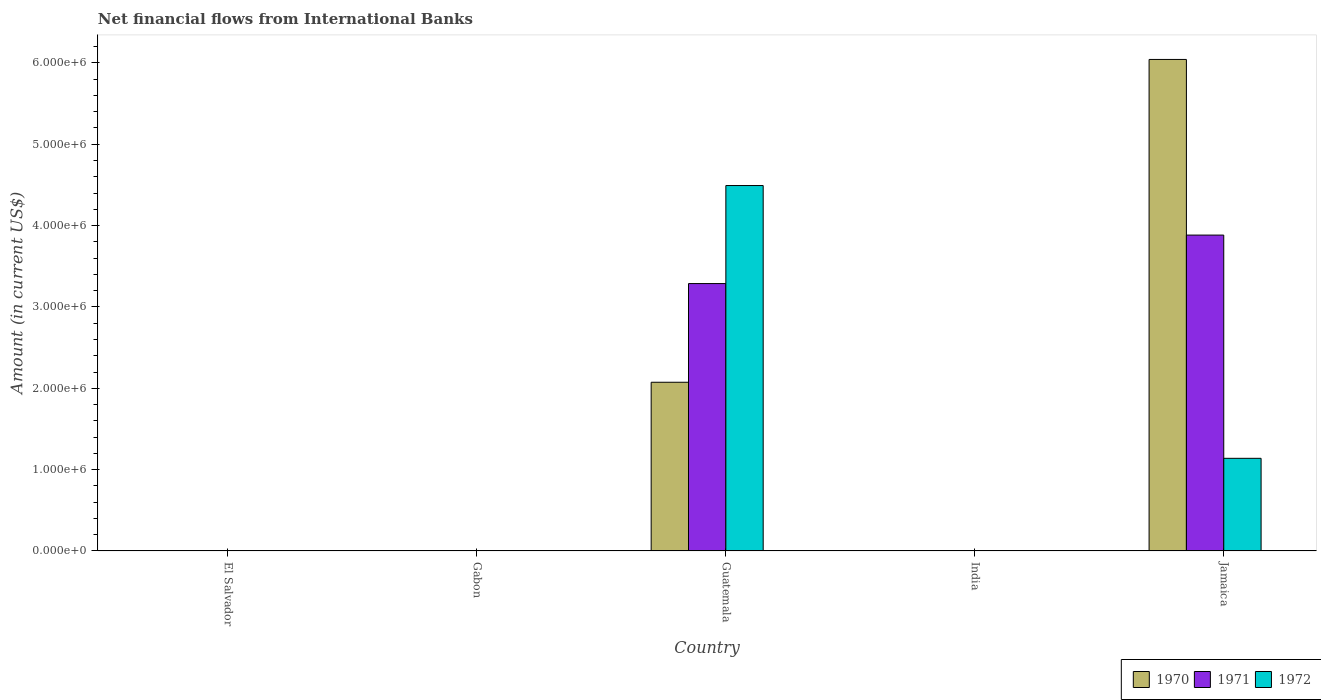How many different coloured bars are there?
Your answer should be very brief. 3. Are the number of bars per tick equal to the number of legend labels?
Your response must be concise. No. How many bars are there on the 3rd tick from the right?
Your response must be concise. 3. What is the label of the 2nd group of bars from the left?
Offer a very short reply. Gabon. In how many cases, is the number of bars for a given country not equal to the number of legend labels?
Ensure brevity in your answer.  3. Across all countries, what is the maximum net financial aid flows in 1972?
Give a very brief answer. 4.49e+06. Across all countries, what is the minimum net financial aid flows in 1972?
Ensure brevity in your answer.  0. In which country was the net financial aid flows in 1972 maximum?
Offer a very short reply. Guatemala. What is the total net financial aid flows in 1970 in the graph?
Provide a succinct answer. 8.12e+06. What is the difference between the net financial aid flows in 1971 in Guatemala and that in Jamaica?
Offer a very short reply. -5.96e+05. What is the average net financial aid flows in 1970 per country?
Your answer should be compact. 1.62e+06. What is the difference between the net financial aid flows of/in 1971 and net financial aid flows of/in 1972 in Jamaica?
Provide a succinct answer. 2.74e+06. What is the ratio of the net financial aid flows in 1972 in Guatemala to that in Jamaica?
Make the answer very short. 3.94. What is the difference between the highest and the lowest net financial aid flows in 1971?
Offer a terse response. 3.88e+06. Is the sum of the net financial aid flows in 1971 in Guatemala and Jamaica greater than the maximum net financial aid flows in 1972 across all countries?
Ensure brevity in your answer.  Yes. Is it the case that in every country, the sum of the net financial aid flows in 1972 and net financial aid flows in 1971 is greater than the net financial aid flows in 1970?
Ensure brevity in your answer.  No. How many countries are there in the graph?
Provide a short and direct response. 5. What is the difference between two consecutive major ticks on the Y-axis?
Offer a very short reply. 1.00e+06. Are the values on the major ticks of Y-axis written in scientific E-notation?
Your response must be concise. Yes. Does the graph contain grids?
Give a very brief answer. No. How are the legend labels stacked?
Offer a terse response. Horizontal. What is the title of the graph?
Your answer should be very brief. Net financial flows from International Banks. Does "2003" appear as one of the legend labels in the graph?
Ensure brevity in your answer.  No. What is the label or title of the X-axis?
Provide a short and direct response. Country. What is the label or title of the Y-axis?
Provide a succinct answer. Amount (in current US$). What is the Amount (in current US$) of 1971 in El Salvador?
Provide a succinct answer. 0. What is the Amount (in current US$) of 1972 in Gabon?
Offer a terse response. 0. What is the Amount (in current US$) of 1970 in Guatemala?
Your response must be concise. 2.07e+06. What is the Amount (in current US$) of 1971 in Guatemala?
Your response must be concise. 3.29e+06. What is the Amount (in current US$) of 1972 in Guatemala?
Offer a terse response. 4.49e+06. What is the Amount (in current US$) in 1971 in India?
Offer a very short reply. 0. What is the Amount (in current US$) in 1972 in India?
Your answer should be compact. 0. What is the Amount (in current US$) in 1970 in Jamaica?
Give a very brief answer. 6.04e+06. What is the Amount (in current US$) of 1971 in Jamaica?
Offer a very short reply. 3.88e+06. What is the Amount (in current US$) of 1972 in Jamaica?
Your answer should be compact. 1.14e+06. Across all countries, what is the maximum Amount (in current US$) in 1970?
Your response must be concise. 6.04e+06. Across all countries, what is the maximum Amount (in current US$) of 1971?
Ensure brevity in your answer.  3.88e+06. Across all countries, what is the maximum Amount (in current US$) in 1972?
Give a very brief answer. 4.49e+06. Across all countries, what is the minimum Amount (in current US$) in 1970?
Ensure brevity in your answer.  0. Across all countries, what is the minimum Amount (in current US$) of 1972?
Your response must be concise. 0. What is the total Amount (in current US$) in 1970 in the graph?
Offer a very short reply. 8.12e+06. What is the total Amount (in current US$) of 1971 in the graph?
Provide a succinct answer. 7.17e+06. What is the total Amount (in current US$) in 1972 in the graph?
Your answer should be compact. 5.63e+06. What is the difference between the Amount (in current US$) of 1970 in Guatemala and that in Jamaica?
Your answer should be very brief. -3.97e+06. What is the difference between the Amount (in current US$) of 1971 in Guatemala and that in Jamaica?
Give a very brief answer. -5.96e+05. What is the difference between the Amount (in current US$) in 1972 in Guatemala and that in Jamaica?
Ensure brevity in your answer.  3.35e+06. What is the difference between the Amount (in current US$) of 1970 in Guatemala and the Amount (in current US$) of 1971 in Jamaica?
Your answer should be very brief. -1.81e+06. What is the difference between the Amount (in current US$) of 1970 in Guatemala and the Amount (in current US$) of 1972 in Jamaica?
Your answer should be very brief. 9.35e+05. What is the difference between the Amount (in current US$) of 1971 in Guatemala and the Amount (in current US$) of 1972 in Jamaica?
Provide a succinct answer. 2.15e+06. What is the average Amount (in current US$) in 1970 per country?
Your answer should be compact. 1.62e+06. What is the average Amount (in current US$) in 1971 per country?
Your response must be concise. 1.43e+06. What is the average Amount (in current US$) in 1972 per country?
Offer a very short reply. 1.13e+06. What is the difference between the Amount (in current US$) of 1970 and Amount (in current US$) of 1971 in Guatemala?
Provide a succinct answer. -1.21e+06. What is the difference between the Amount (in current US$) in 1970 and Amount (in current US$) in 1972 in Guatemala?
Provide a succinct answer. -2.42e+06. What is the difference between the Amount (in current US$) of 1971 and Amount (in current US$) of 1972 in Guatemala?
Provide a succinct answer. -1.20e+06. What is the difference between the Amount (in current US$) in 1970 and Amount (in current US$) in 1971 in Jamaica?
Provide a short and direct response. 2.16e+06. What is the difference between the Amount (in current US$) of 1970 and Amount (in current US$) of 1972 in Jamaica?
Ensure brevity in your answer.  4.90e+06. What is the difference between the Amount (in current US$) of 1971 and Amount (in current US$) of 1972 in Jamaica?
Provide a succinct answer. 2.74e+06. What is the ratio of the Amount (in current US$) in 1970 in Guatemala to that in Jamaica?
Provide a short and direct response. 0.34. What is the ratio of the Amount (in current US$) in 1971 in Guatemala to that in Jamaica?
Provide a succinct answer. 0.85. What is the ratio of the Amount (in current US$) of 1972 in Guatemala to that in Jamaica?
Make the answer very short. 3.94. What is the difference between the highest and the lowest Amount (in current US$) in 1970?
Your answer should be very brief. 6.04e+06. What is the difference between the highest and the lowest Amount (in current US$) of 1971?
Your answer should be compact. 3.88e+06. What is the difference between the highest and the lowest Amount (in current US$) of 1972?
Make the answer very short. 4.49e+06. 